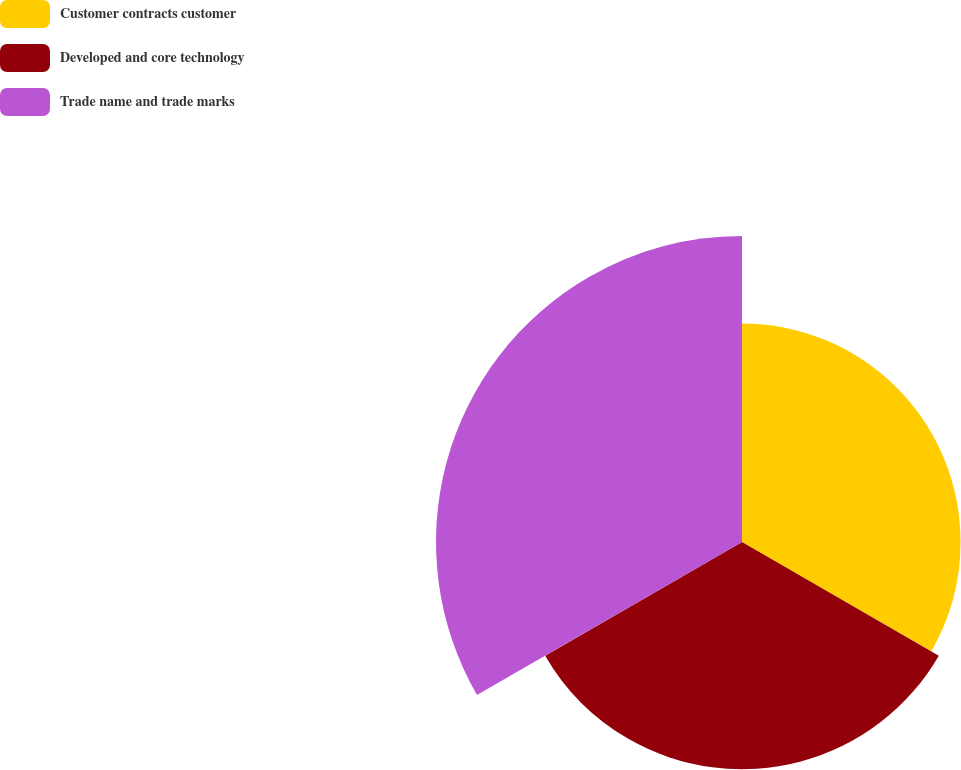Convert chart. <chart><loc_0><loc_0><loc_500><loc_500><pie_chart><fcel>Customer contracts customer<fcel>Developed and core technology<fcel>Trade name and trade marks<nl><fcel>29.07%<fcel>30.23%<fcel>40.7%<nl></chart> 